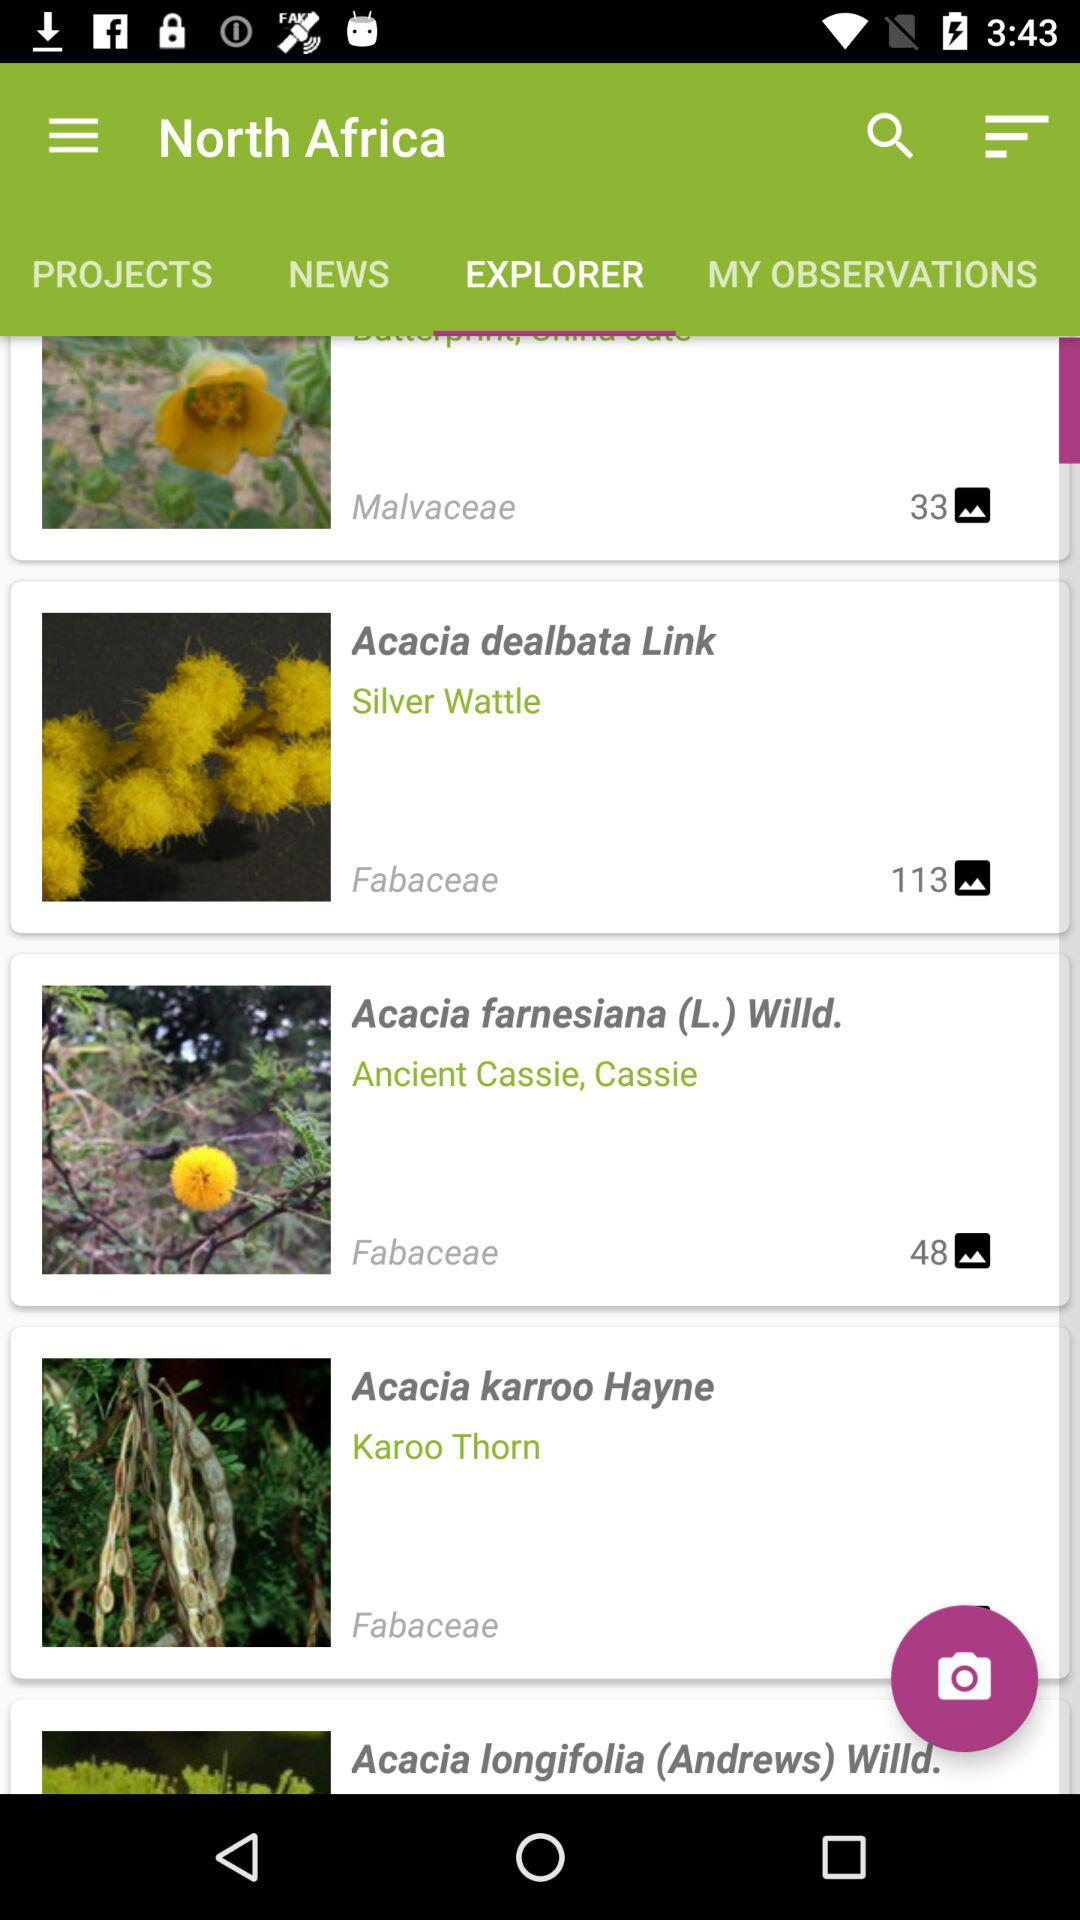Which tab is selected? The selected tab is "EXPLORER". 